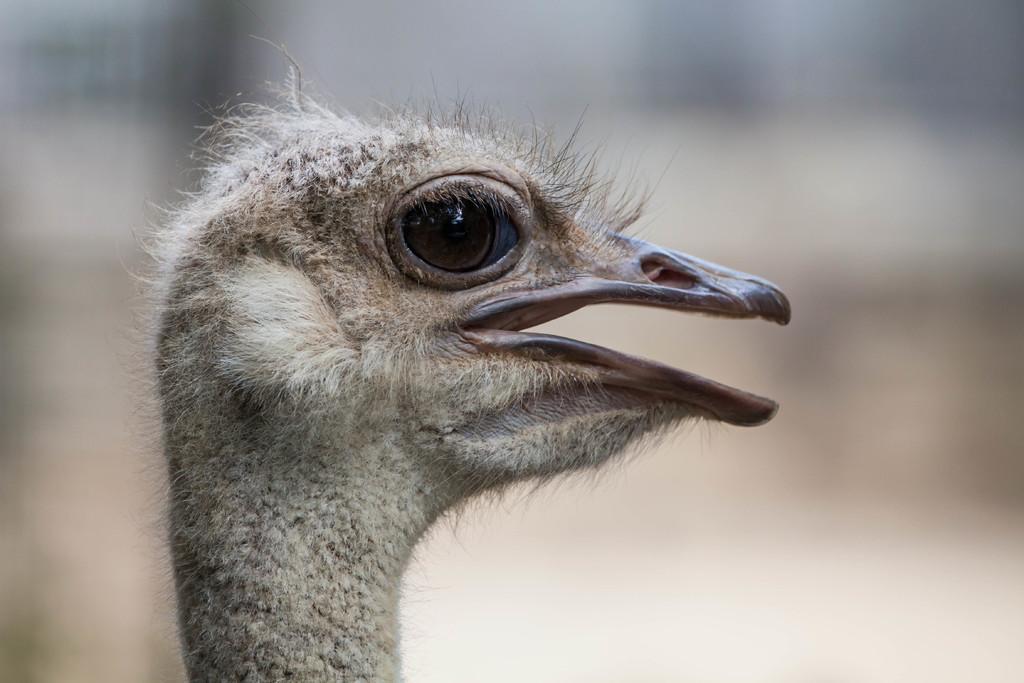Can you describe this image briefly? On the left side, there is a gray color bird having opened its mouth. And the background is blurred. 